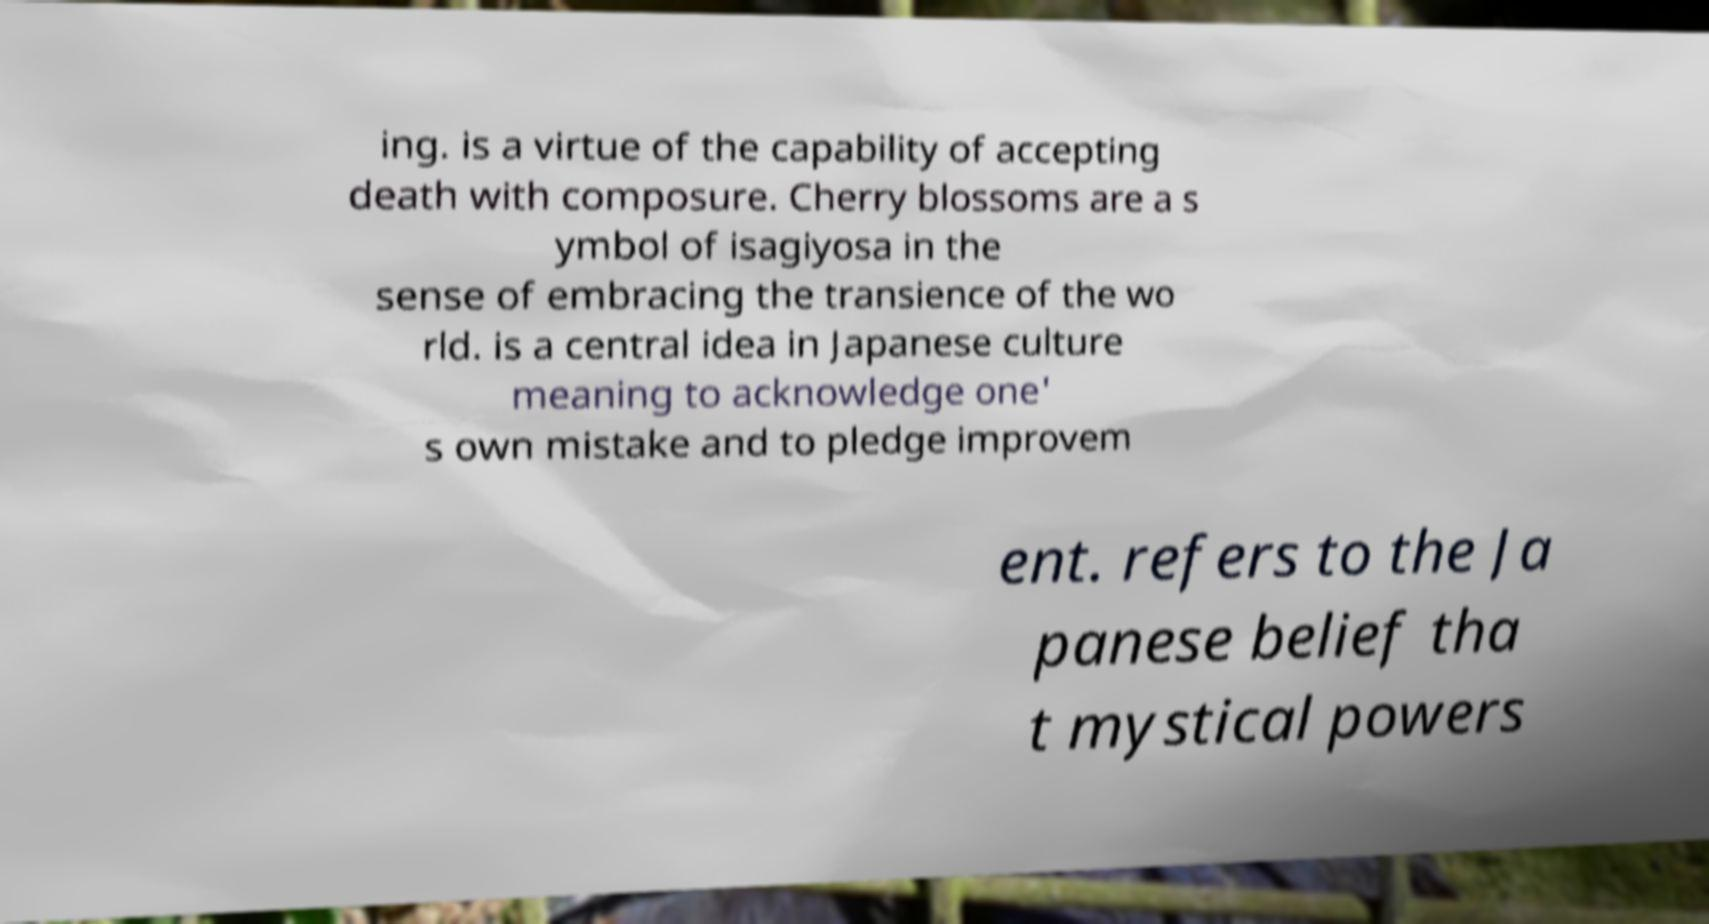Please read and relay the text visible in this image. What does it say? ing. is a virtue of the capability of accepting death with composure. Cherry blossoms are a s ymbol of isagiyosa in the sense of embracing the transience of the wo rld. is a central idea in Japanese culture meaning to acknowledge one' s own mistake and to pledge improvem ent. refers to the Ja panese belief tha t mystical powers 